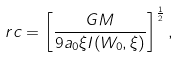Convert formula to latex. <formula><loc_0><loc_0><loc_500><loc_500>\ r c = \left [ \frac { G M } { 9 a _ { 0 } \xi I ( W _ { 0 } , \xi ) } \right ] ^ { \frac { 1 } { 2 } } ,</formula> 